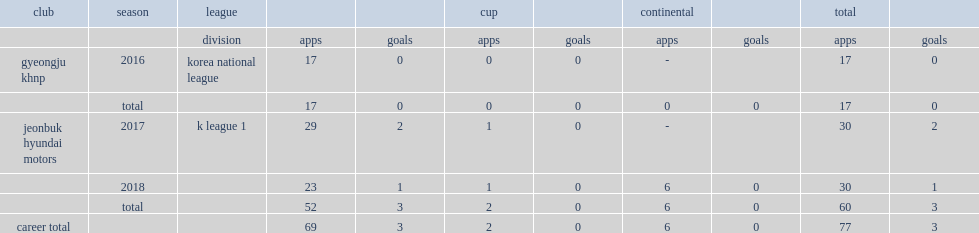Which club did kim play for in 2016? Gyeongju khnp. 